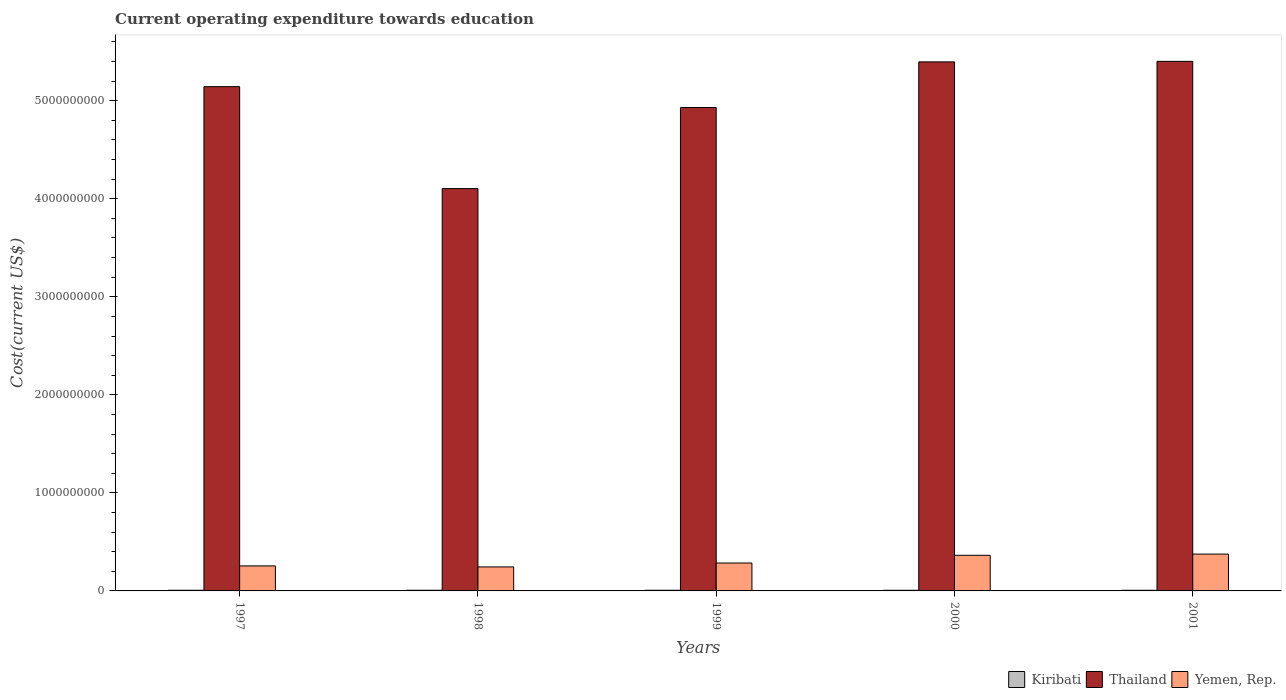How many groups of bars are there?
Make the answer very short. 5. Are the number of bars on each tick of the X-axis equal?
Offer a very short reply. Yes. What is the expenditure towards education in Yemen, Rep. in 1998?
Provide a short and direct response. 2.45e+08. Across all years, what is the maximum expenditure towards education in Kiribati?
Offer a terse response. 6.98e+06. Across all years, what is the minimum expenditure towards education in Kiribati?
Provide a short and direct response. 6.66e+06. In which year was the expenditure towards education in Thailand maximum?
Ensure brevity in your answer.  2001. What is the total expenditure towards education in Kiribati in the graph?
Offer a terse response. 3.40e+07. What is the difference between the expenditure towards education in Thailand in 1997 and that in 1999?
Give a very brief answer. 2.13e+08. What is the difference between the expenditure towards education in Yemen, Rep. in 1997 and the expenditure towards education in Thailand in 2001?
Make the answer very short. -5.15e+09. What is the average expenditure towards education in Kiribati per year?
Your response must be concise. 6.79e+06. In the year 1997, what is the difference between the expenditure towards education in Thailand and expenditure towards education in Yemen, Rep.?
Make the answer very short. 4.89e+09. What is the ratio of the expenditure towards education in Yemen, Rep. in 1997 to that in 2000?
Your response must be concise. 0.7. What is the difference between the highest and the second highest expenditure towards education in Thailand?
Keep it short and to the point. 5.35e+06. What is the difference between the highest and the lowest expenditure towards education in Kiribati?
Provide a short and direct response. 3.27e+05. What does the 1st bar from the left in 1998 represents?
Give a very brief answer. Kiribati. What does the 3rd bar from the right in 2001 represents?
Offer a terse response. Kiribati. How many bars are there?
Offer a very short reply. 15. How many years are there in the graph?
Your response must be concise. 5. Are the values on the major ticks of Y-axis written in scientific E-notation?
Ensure brevity in your answer.  No. Does the graph contain grids?
Keep it short and to the point. No. How many legend labels are there?
Provide a succinct answer. 3. What is the title of the graph?
Give a very brief answer. Current operating expenditure towards education. Does "Pacific island small states" appear as one of the legend labels in the graph?
Provide a succinct answer. No. What is the label or title of the X-axis?
Your answer should be compact. Years. What is the label or title of the Y-axis?
Give a very brief answer. Cost(current US$). What is the Cost(current US$) in Kiribati in 1997?
Your response must be concise. 6.83e+06. What is the Cost(current US$) in Thailand in 1997?
Offer a very short reply. 5.14e+09. What is the Cost(current US$) of Yemen, Rep. in 1997?
Offer a terse response. 2.55e+08. What is the Cost(current US$) of Kiribati in 1998?
Your answer should be very brief. 6.98e+06. What is the Cost(current US$) in Thailand in 1998?
Give a very brief answer. 4.10e+09. What is the Cost(current US$) of Yemen, Rep. in 1998?
Your answer should be compact. 2.45e+08. What is the Cost(current US$) in Kiribati in 1999?
Your response must be concise. 6.82e+06. What is the Cost(current US$) in Thailand in 1999?
Provide a short and direct response. 4.93e+09. What is the Cost(current US$) in Yemen, Rep. in 1999?
Your answer should be very brief. 2.85e+08. What is the Cost(current US$) in Kiribati in 2000?
Offer a terse response. 6.67e+06. What is the Cost(current US$) of Thailand in 2000?
Give a very brief answer. 5.40e+09. What is the Cost(current US$) in Yemen, Rep. in 2000?
Provide a short and direct response. 3.63e+08. What is the Cost(current US$) in Kiribati in 2001?
Make the answer very short. 6.66e+06. What is the Cost(current US$) of Thailand in 2001?
Provide a succinct answer. 5.40e+09. What is the Cost(current US$) of Yemen, Rep. in 2001?
Provide a short and direct response. 3.76e+08. Across all years, what is the maximum Cost(current US$) of Kiribati?
Give a very brief answer. 6.98e+06. Across all years, what is the maximum Cost(current US$) in Thailand?
Keep it short and to the point. 5.40e+09. Across all years, what is the maximum Cost(current US$) in Yemen, Rep.?
Make the answer very short. 3.76e+08. Across all years, what is the minimum Cost(current US$) in Kiribati?
Provide a succinct answer. 6.66e+06. Across all years, what is the minimum Cost(current US$) of Thailand?
Your answer should be compact. 4.10e+09. Across all years, what is the minimum Cost(current US$) in Yemen, Rep.?
Your response must be concise. 2.45e+08. What is the total Cost(current US$) of Kiribati in the graph?
Keep it short and to the point. 3.40e+07. What is the total Cost(current US$) of Thailand in the graph?
Your answer should be very brief. 2.50e+1. What is the total Cost(current US$) in Yemen, Rep. in the graph?
Offer a very short reply. 1.52e+09. What is the difference between the Cost(current US$) of Kiribati in 1997 and that in 1998?
Your answer should be very brief. -1.55e+05. What is the difference between the Cost(current US$) in Thailand in 1997 and that in 1998?
Your response must be concise. 1.04e+09. What is the difference between the Cost(current US$) in Yemen, Rep. in 1997 and that in 1998?
Offer a terse response. 1.06e+07. What is the difference between the Cost(current US$) of Kiribati in 1997 and that in 1999?
Give a very brief answer. 7282.92. What is the difference between the Cost(current US$) in Thailand in 1997 and that in 1999?
Your answer should be compact. 2.13e+08. What is the difference between the Cost(current US$) in Yemen, Rep. in 1997 and that in 1999?
Offer a terse response. -2.95e+07. What is the difference between the Cost(current US$) in Kiribati in 1997 and that in 2000?
Your answer should be very brief. 1.61e+05. What is the difference between the Cost(current US$) of Thailand in 1997 and that in 2000?
Your response must be concise. -2.53e+08. What is the difference between the Cost(current US$) in Yemen, Rep. in 1997 and that in 2000?
Your response must be concise. -1.08e+08. What is the difference between the Cost(current US$) of Kiribati in 1997 and that in 2001?
Offer a terse response. 1.73e+05. What is the difference between the Cost(current US$) in Thailand in 1997 and that in 2001?
Offer a very short reply. -2.58e+08. What is the difference between the Cost(current US$) of Yemen, Rep. in 1997 and that in 2001?
Your answer should be very brief. -1.20e+08. What is the difference between the Cost(current US$) in Kiribati in 1998 and that in 1999?
Keep it short and to the point. 1.62e+05. What is the difference between the Cost(current US$) of Thailand in 1998 and that in 1999?
Offer a terse response. -8.27e+08. What is the difference between the Cost(current US$) in Yemen, Rep. in 1998 and that in 1999?
Offer a very short reply. -4.01e+07. What is the difference between the Cost(current US$) in Kiribati in 1998 and that in 2000?
Provide a short and direct response. 3.16e+05. What is the difference between the Cost(current US$) in Thailand in 1998 and that in 2000?
Your answer should be very brief. -1.29e+09. What is the difference between the Cost(current US$) in Yemen, Rep. in 1998 and that in 2000?
Provide a succinct answer. -1.19e+08. What is the difference between the Cost(current US$) of Kiribati in 1998 and that in 2001?
Make the answer very short. 3.27e+05. What is the difference between the Cost(current US$) in Thailand in 1998 and that in 2001?
Offer a terse response. -1.30e+09. What is the difference between the Cost(current US$) in Yemen, Rep. in 1998 and that in 2001?
Give a very brief answer. -1.31e+08. What is the difference between the Cost(current US$) of Kiribati in 1999 and that in 2000?
Give a very brief answer. 1.54e+05. What is the difference between the Cost(current US$) of Thailand in 1999 and that in 2000?
Your answer should be compact. -4.66e+08. What is the difference between the Cost(current US$) of Yemen, Rep. in 1999 and that in 2000?
Your answer should be compact. -7.86e+07. What is the difference between the Cost(current US$) of Kiribati in 1999 and that in 2001?
Offer a terse response. 1.65e+05. What is the difference between the Cost(current US$) in Thailand in 1999 and that in 2001?
Your response must be concise. -4.71e+08. What is the difference between the Cost(current US$) of Yemen, Rep. in 1999 and that in 2001?
Offer a terse response. -9.09e+07. What is the difference between the Cost(current US$) of Kiribati in 2000 and that in 2001?
Your response must be concise. 1.12e+04. What is the difference between the Cost(current US$) in Thailand in 2000 and that in 2001?
Give a very brief answer. -5.35e+06. What is the difference between the Cost(current US$) in Yemen, Rep. in 2000 and that in 2001?
Ensure brevity in your answer.  -1.23e+07. What is the difference between the Cost(current US$) in Kiribati in 1997 and the Cost(current US$) in Thailand in 1998?
Offer a very short reply. -4.10e+09. What is the difference between the Cost(current US$) of Kiribati in 1997 and the Cost(current US$) of Yemen, Rep. in 1998?
Ensure brevity in your answer.  -2.38e+08. What is the difference between the Cost(current US$) in Thailand in 1997 and the Cost(current US$) in Yemen, Rep. in 1998?
Provide a succinct answer. 4.90e+09. What is the difference between the Cost(current US$) in Kiribati in 1997 and the Cost(current US$) in Thailand in 1999?
Make the answer very short. -4.92e+09. What is the difference between the Cost(current US$) in Kiribati in 1997 and the Cost(current US$) in Yemen, Rep. in 1999?
Provide a succinct answer. -2.78e+08. What is the difference between the Cost(current US$) in Thailand in 1997 and the Cost(current US$) in Yemen, Rep. in 1999?
Offer a terse response. 4.86e+09. What is the difference between the Cost(current US$) in Kiribati in 1997 and the Cost(current US$) in Thailand in 2000?
Offer a terse response. -5.39e+09. What is the difference between the Cost(current US$) in Kiribati in 1997 and the Cost(current US$) in Yemen, Rep. in 2000?
Provide a short and direct response. -3.57e+08. What is the difference between the Cost(current US$) in Thailand in 1997 and the Cost(current US$) in Yemen, Rep. in 2000?
Offer a very short reply. 4.78e+09. What is the difference between the Cost(current US$) in Kiribati in 1997 and the Cost(current US$) in Thailand in 2001?
Your response must be concise. -5.39e+09. What is the difference between the Cost(current US$) of Kiribati in 1997 and the Cost(current US$) of Yemen, Rep. in 2001?
Give a very brief answer. -3.69e+08. What is the difference between the Cost(current US$) in Thailand in 1997 and the Cost(current US$) in Yemen, Rep. in 2001?
Your answer should be very brief. 4.77e+09. What is the difference between the Cost(current US$) of Kiribati in 1998 and the Cost(current US$) of Thailand in 1999?
Ensure brevity in your answer.  -4.92e+09. What is the difference between the Cost(current US$) in Kiribati in 1998 and the Cost(current US$) in Yemen, Rep. in 1999?
Your response must be concise. -2.78e+08. What is the difference between the Cost(current US$) in Thailand in 1998 and the Cost(current US$) in Yemen, Rep. in 1999?
Your response must be concise. 3.82e+09. What is the difference between the Cost(current US$) of Kiribati in 1998 and the Cost(current US$) of Thailand in 2000?
Your answer should be very brief. -5.39e+09. What is the difference between the Cost(current US$) in Kiribati in 1998 and the Cost(current US$) in Yemen, Rep. in 2000?
Give a very brief answer. -3.56e+08. What is the difference between the Cost(current US$) of Thailand in 1998 and the Cost(current US$) of Yemen, Rep. in 2000?
Keep it short and to the point. 3.74e+09. What is the difference between the Cost(current US$) in Kiribati in 1998 and the Cost(current US$) in Thailand in 2001?
Your answer should be compact. -5.39e+09. What is the difference between the Cost(current US$) of Kiribati in 1998 and the Cost(current US$) of Yemen, Rep. in 2001?
Make the answer very short. -3.69e+08. What is the difference between the Cost(current US$) in Thailand in 1998 and the Cost(current US$) in Yemen, Rep. in 2001?
Ensure brevity in your answer.  3.73e+09. What is the difference between the Cost(current US$) in Kiribati in 1999 and the Cost(current US$) in Thailand in 2000?
Your response must be concise. -5.39e+09. What is the difference between the Cost(current US$) in Kiribati in 1999 and the Cost(current US$) in Yemen, Rep. in 2000?
Ensure brevity in your answer.  -3.57e+08. What is the difference between the Cost(current US$) in Thailand in 1999 and the Cost(current US$) in Yemen, Rep. in 2000?
Your response must be concise. 4.57e+09. What is the difference between the Cost(current US$) in Kiribati in 1999 and the Cost(current US$) in Thailand in 2001?
Offer a terse response. -5.39e+09. What is the difference between the Cost(current US$) in Kiribati in 1999 and the Cost(current US$) in Yemen, Rep. in 2001?
Provide a succinct answer. -3.69e+08. What is the difference between the Cost(current US$) of Thailand in 1999 and the Cost(current US$) of Yemen, Rep. in 2001?
Ensure brevity in your answer.  4.55e+09. What is the difference between the Cost(current US$) in Kiribati in 2000 and the Cost(current US$) in Thailand in 2001?
Your response must be concise. -5.39e+09. What is the difference between the Cost(current US$) of Kiribati in 2000 and the Cost(current US$) of Yemen, Rep. in 2001?
Ensure brevity in your answer.  -3.69e+08. What is the difference between the Cost(current US$) of Thailand in 2000 and the Cost(current US$) of Yemen, Rep. in 2001?
Your response must be concise. 5.02e+09. What is the average Cost(current US$) of Kiribati per year?
Offer a terse response. 6.79e+06. What is the average Cost(current US$) in Thailand per year?
Your answer should be very brief. 5.00e+09. What is the average Cost(current US$) in Yemen, Rep. per year?
Ensure brevity in your answer.  3.05e+08. In the year 1997, what is the difference between the Cost(current US$) in Kiribati and Cost(current US$) in Thailand?
Provide a succinct answer. -5.14e+09. In the year 1997, what is the difference between the Cost(current US$) of Kiribati and Cost(current US$) of Yemen, Rep.?
Provide a short and direct response. -2.48e+08. In the year 1997, what is the difference between the Cost(current US$) in Thailand and Cost(current US$) in Yemen, Rep.?
Keep it short and to the point. 4.89e+09. In the year 1998, what is the difference between the Cost(current US$) in Kiribati and Cost(current US$) in Thailand?
Your answer should be very brief. -4.10e+09. In the year 1998, what is the difference between the Cost(current US$) of Kiribati and Cost(current US$) of Yemen, Rep.?
Make the answer very short. -2.38e+08. In the year 1998, what is the difference between the Cost(current US$) in Thailand and Cost(current US$) in Yemen, Rep.?
Provide a short and direct response. 3.86e+09. In the year 1999, what is the difference between the Cost(current US$) in Kiribati and Cost(current US$) in Thailand?
Ensure brevity in your answer.  -4.92e+09. In the year 1999, what is the difference between the Cost(current US$) of Kiribati and Cost(current US$) of Yemen, Rep.?
Keep it short and to the point. -2.78e+08. In the year 1999, what is the difference between the Cost(current US$) of Thailand and Cost(current US$) of Yemen, Rep.?
Offer a very short reply. 4.65e+09. In the year 2000, what is the difference between the Cost(current US$) in Kiribati and Cost(current US$) in Thailand?
Offer a very short reply. -5.39e+09. In the year 2000, what is the difference between the Cost(current US$) in Kiribati and Cost(current US$) in Yemen, Rep.?
Give a very brief answer. -3.57e+08. In the year 2000, what is the difference between the Cost(current US$) of Thailand and Cost(current US$) of Yemen, Rep.?
Offer a very short reply. 5.03e+09. In the year 2001, what is the difference between the Cost(current US$) in Kiribati and Cost(current US$) in Thailand?
Ensure brevity in your answer.  -5.39e+09. In the year 2001, what is the difference between the Cost(current US$) of Kiribati and Cost(current US$) of Yemen, Rep.?
Your response must be concise. -3.69e+08. In the year 2001, what is the difference between the Cost(current US$) of Thailand and Cost(current US$) of Yemen, Rep.?
Your response must be concise. 5.03e+09. What is the ratio of the Cost(current US$) of Kiribati in 1997 to that in 1998?
Offer a very short reply. 0.98. What is the ratio of the Cost(current US$) in Thailand in 1997 to that in 1998?
Your answer should be very brief. 1.25. What is the ratio of the Cost(current US$) in Yemen, Rep. in 1997 to that in 1998?
Your response must be concise. 1.04. What is the ratio of the Cost(current US$) of Kiribati in 1997 to that in 1999?
Offer a terse response. 1. What is the ratio of the Cost(current US$) in Thailand in 1997 to that in 1999?
Provide a succinct answer. 1.04. What is the ratio of the Cost(current US$) in Yemen, Rep. in 1997 to that in 1999?
Ensure brevity in your answer.  0.9. What is the ratio of the Cost(current US$) of Kiribati in 1997 to that in 2000?
Make the answer very short. 1.02. What is the ratio of the Cost(current US$) of Thailand in 1997 to that in 2000?
Your answer should be compact. 0.95. What is the ratio of the Cost(current US$) of Yemen, Rep. in 1997 to that in 2000?
Provide a succinct answer. 0.7. What is the ratio of the Cost(current US$) of Kiribati in 1997 to that in 2001?
Provide a succinct answer. 1.03. What is the ratio of the Cost(current US$) of Thailand in 1997 to that in 2001?
Make the answer very short. 0.95. What is the ratio of the Cost(current US$) of Yemen, Rep. in 1997 to that in 2001?
Provide a succinct answer. 0.68. What is the ratio of the Cost(current US$) of Kiribati in 1998 to that in 1999?
Offer a terse response. 1.02. What is the ratio of the Cost(current US$) of Thailand in 1998 to that in 1999?
Offer a very short reply. 0.83. What is the ratio of the Cost(current US$) of Yemen, Rep. in 1998 to that in 1999?
Provide a short and direct response. 0.86. What is the ratio of the Cost(current US$) in Kiribati in 1998 to that in 2000?
Offer a very short reply. 1.05. What is the ratio of the Cost(current US$) of Thailand in 1998 to that in 2000?
Provide a short and direct response. 0.76. What is the ratio of the Cost(current US$) in Yemen, Rep. in 1998 to that in 2000?
Make the answer very short. 0.67. What is the ratio of the Cost(current US$) of Kiribati in 1998 to that in 2001?
Keep it short and to the point. 1.05. What is the ratio of the Cost(current US$) in Thailand in 1998 to that in 2001?
Your answer should be compact. 0.76. What is the ratio of the Cost(current US$) of Yemen, Rep. in 1998 to that in 2001?
Provide a short and direct response. 0.65. What is the ratio of the Cost(current US$) in Kiribati in 1999 to that in 2000?
Your response must be concise. 1.02. What is the ratio of the Cost(current US$) in Thailand in 1999 to that in 2000?
Your response must be concise. 0.91. What is the ratio of the Cost(current US$) in Yemen, Rep. in 1999 to that in 2000?
Offer a terse response. 0.78. What is the ratio of the Cost(current US$) of Kiribati in 1999 to that in 2001?
Make the answer very short. 1.02. What is the ratio of the Cost(current US$) of Thailand in 1999 to that in 2001?
Keep it short and to the point. 0.91. What is the ratio of the Cost(current US$) of Yemen, Rep. in 1999 to that in 2001?
Give a very brief answer. 0.76. What is the ratio of the Cost(current US$) in Yemen, Rep. in 2000 to that in 2001?
Make the answer very short. 0.97. What is the difference between the highest and the second highest Cost(current US$) of Kiribati?
Make the answer very short. 1.55e+05. What is the difference between the highest and the second highest Cost(current US$) in Thailand?
Your answer should be compact. 5.35e+06. What is the difference between the highest and the second highest Cost(current US$) of Yemen, Rep.?
Give a very brief answer. 1.23e+07. What is the difference between the highest and the lowest Cost(current US$) in Kiribati?
Provide a short and direct response. 3.27e+05. What is the difference between the highest and the lowest Cost(current US$) of Thailand?
Your response must be concise. 1.30e+09. What is the difference between the highest and the lowest Cost(current US$) of Yemen, Rep.?
Your response must be concise. 1.31e+08. 